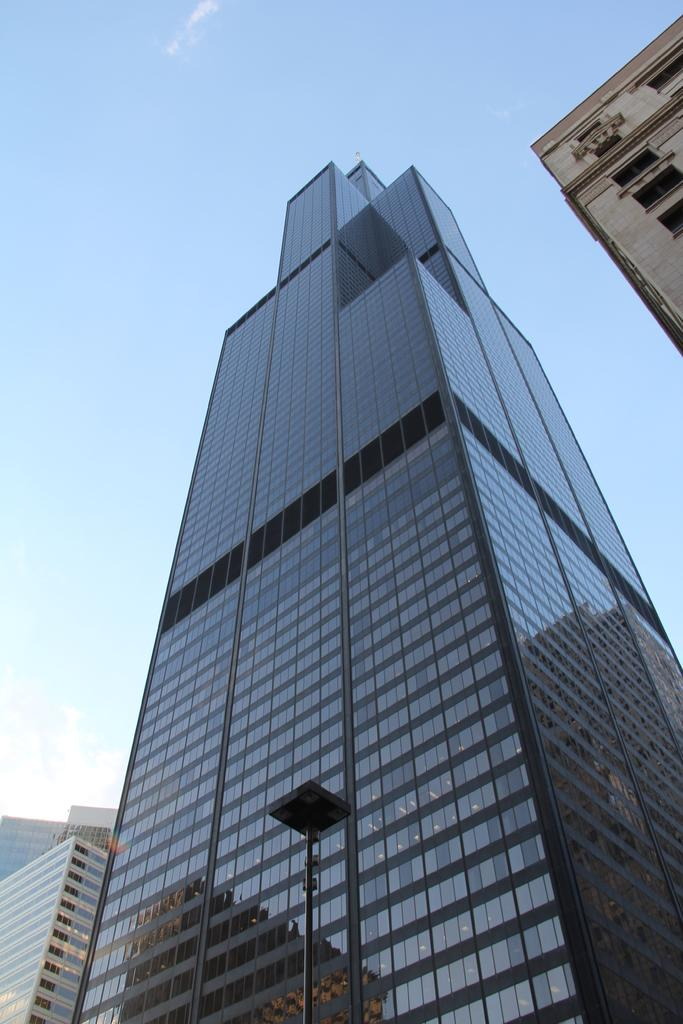What is the main subject of the image? The main subject of the image is many buildings. Can you describe any specific features of the buildings? Unfortunately, the provided facts do not mention any specific features of the buildings. What is located in front of one of the buildings? There is a pole in front of a building. What can be seen in the background of the image? The sky is visible in the background of the image. What type of debt is being discussed at the meeting in the image? There is no meeting or discussion of debt present in the image. The image primarily features buildings and a pole in front of one of them. 